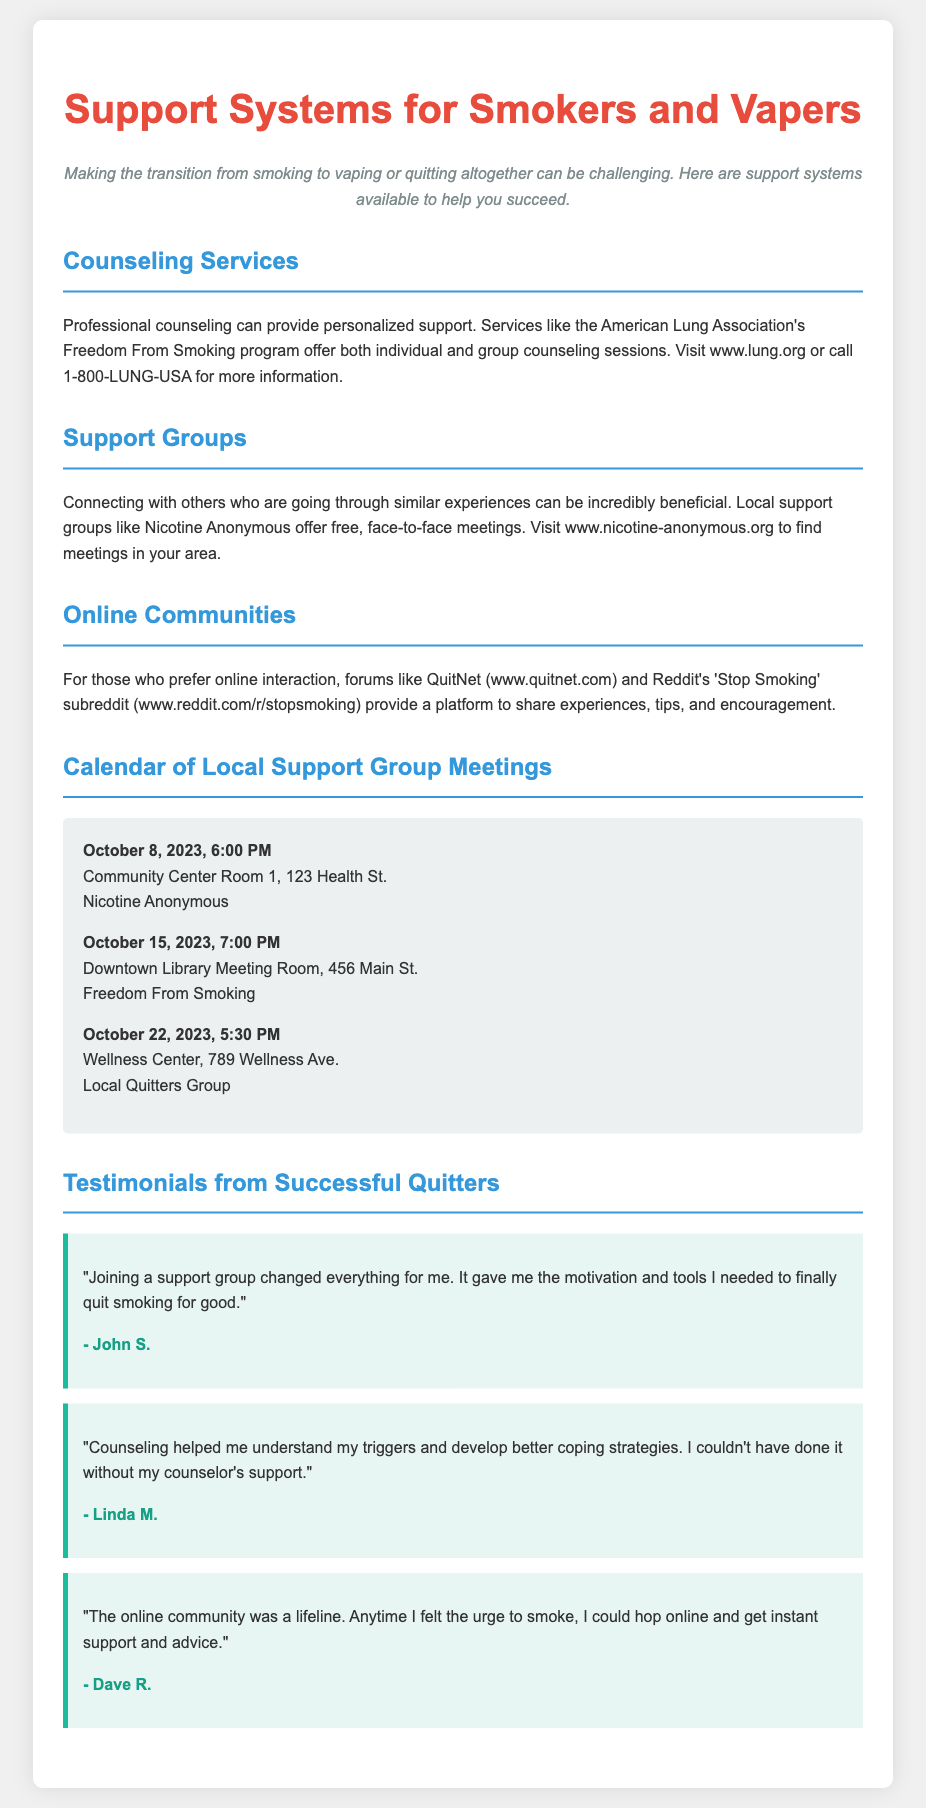What are the counseling services mentioned? The document mentions the American Lung Association's Freedom From Smoking program as a counseling service.
Answer: Freedom From Smoking When is the next Nicotine Anonymous meeting? The document provides a calendar with meeting details, indicating the next Nicotine Anonymous meeting is on October 8, 2023.
Answer: October 8, 2023 What is the address for the Freedom From Smoking meeting? The document lists the address for the Freedom From Smoking meeting as Downtown Library Meeting Room, 456 Main St.
Answer: Downtown Library Meeting Room, 456 Main St Who is John S.? John S. is a successful quitter whose testimonial is included in the flyer, highlighting the impact of joining a support group.
Answer: John S What online forum is mentioned for support? The document lists QuitNet as an online forum for support.
Answer: QuitNet How many testimonials are included in the document? The document includes three testimonials from successful quitters.
Answer: Three What is the purpose of this flyer? The flyer aims to provide information on support systems available for individuals transitioning from smoking to vaping or quitting altogether.
Answer: Support systems for smokers and vapers What type of support can people find locally? The document mentions local support groups as a type of support available.
Answer: Local support groups 